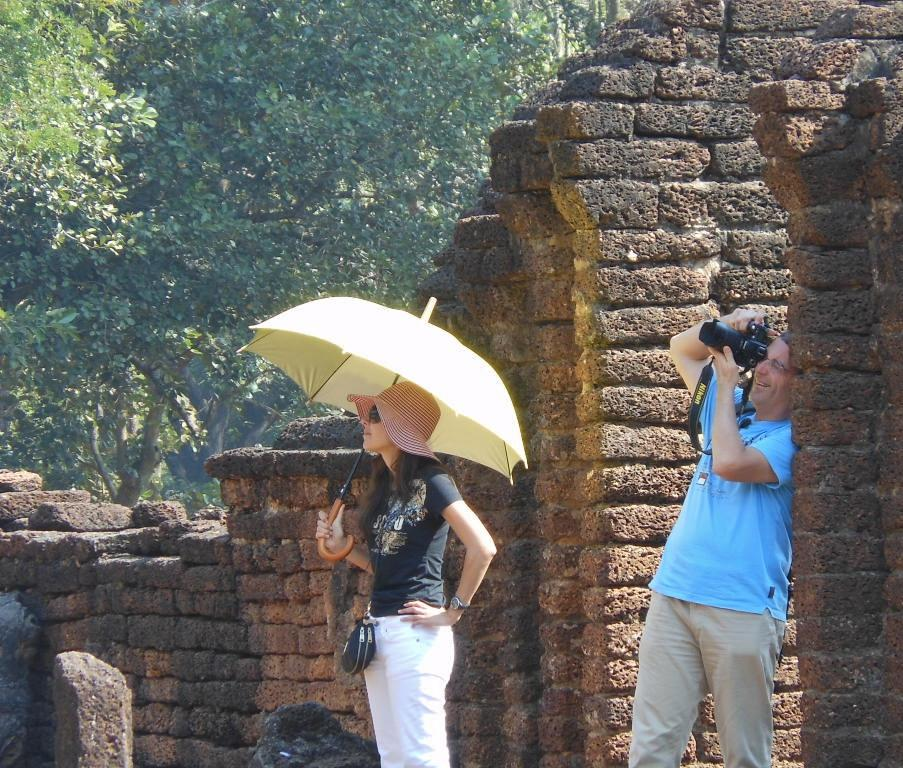Question: what color is the umbrella?
Choices:
A. Black.
B. Red.
C. Yellow.
D. Purple.
Answer with the letter. Answer: C Question: what material is the structure made of?
Choices:
A. Brick.
B. Concrete.
C. Wood.
D. Stone.
Answer with the letter. Answer: A Question: who is wearing a red checked floppy hat?
Choices:
A. The woman.
B. The teacher.
C. The girl.
D. The receptionist.
Answer with the letter. Answer: A Question: who is taking the picture?
Choices:
A. A man in a blue shirt.
B. A girl in a red top.
C. A woman in a green blouse.
D. A boy in a yellow shirt.
Answer with the letter. Answer: A Question: what is the man in the blue shirt doing?
Choices:
A. Getting a photo.
B. Capuring a memory.
C. Taking a snapshot.
D. Taking a picture.
Answer with the letter. Answer: D Question: what is the woman in white pants holding?
Choices:
A. A brown purse.
B. A white cell phone.
C. A yellow umbrella.
D. A bag.
Answer with the letter. Answer: C Question: what color is the umbrella?
Choices:
A. Pink.
B. Red.
C. Green.
D. Yellow.
Answer with the letter. Answer: D Question: what are the ruins made of?
Choices:
A. Red clay.
B. Weathered stone.
C. Old brick.
D. Pure gold.
Answer with the letter. Answer: B Question: what is behind the ruins?
Choices:
A. Leafy trees.
B. A blue lake.
C. A desert.
D. A grassy field.
Answer with the letter. Answer: A Question: where are the leafy trees?
Choices:
A. In front of the lake.
B. At the base of the mountain.
C. Behind the ruins.
D. In the forest.
Answer with the letter. Answer: C Question: who is visiting the ruins?
Choices:
A. A family.
B. Tourists.
C. Americans.
D. A couple.
Answer with the letter. Answer: D Question: what does the couple seem to be enjoying?
Choices:
A. Their trip to the ruins.
B. Each other.
C. The leafy trees.
D. The weather.
Answer with the letter. Answer: A Question: where does the woman wear a watch?
Choices:
A. On her left wrist.
B. On her right wrist.
C. Around her neck.
D. In her pocket.
Answer with the letter. Answer: A Question: what are the two people in casual clothing doing?
Choices:
A. Touring the city.
B. Going for a walk.
C. Shopping at the mall.
D. Looking off into the distance.
Answer with the letter. Answer: D Question: what is the man wearing?
Choices:
A. A trench coat.
B. A watch.
C. A dress suit.
D. Khakis.
Answer with the letter. Answer: D Question: who is wearing khakis?
Choices:
A. The golf attendant.
B. The concert usher.
C. The man.
D. The cashier.
Answer with the letter. Answer: C Question: what is lighting the ruins well?
Choices:
A. The sun.
B. Light.
C. Torches.
D. Flashlight.
Answer with the letter. Answer: A Question: who is looking off into the distance?
Choices:
A. Two people in casual clothing.
B. The artist.
C. The students.
D. The enginer.
Answer with the letter. Answer: A Question: what is the yellow umbrella blocking?
Choices:
A. The rain.
B. The snow.
C. The wind.
D. Bright sunshine.
Answer with the letter. Answer: D Question: how many people are there?
Choices:
A. Three.
B. Four.
C. Five.
D. Two.
Answer with the letter. Answer: D Question: what is the couple doing?
Choices:
A. Eating out.
B. Visiting the ruins.
C. Watching a movie.
D. Holding hands.
Answer with the letter. Answer: B Question: what do the reddish-brown bricks make up?
Choices:
A. The pyramid.
B. The ruins.
C. The building.
D. The house.
Answer with the letter. Answer: B Question: who seems to be enjoying the trip to the ruins?
Choices:
A. The family.
B. The tourists.
C. The couple.
D. The Americans.
Answer with the letter. Answer: C Question: who wears a watch on her left wrist?
Choices:
A. The woman.
B. The receptionist.
C. The right handed person.
D. The teacher.
Answer with the letter. Answer: A Question: who is wearing the sunglasses?
Choices:
A. The teenager.
B. The golfer.
C. The person working outside.
D. The woman.
Answer with the letter. Answer: D Question: what is lighted well by the sun?
Choices:
A. The forest.
B. The ruins.
C. The desert.
D. The ocean.
Answer with the letter. Answer: B Question: who are the tourists?
Choices:
A. The people.
B. The children.
C. The elderly.
D. The couples.
Answer with the letter. Answer: A Question: what are the people?
Choices:
A. Tourists.
B. Civilians.
C. Military.
D. Children.
Answer with the letter. Answer: A Question: what is the umbrella handle?
Choices:
A. Plastic.
B. Steel.
C. Leather.
D. Wooden.
Answer with the letter. Answer: D Question: what is wooden?
Choices:
A. The umbrella handle.
B. The desk.
C. The paddle.
D. The boat.
Answer with the letter. Answer: A Question: who is using a camera?
Choices:
A. The photographer.
B. The tourist.
C. The person.
D. The children.
Answer with the letter. Answer: C Question: what can you not see?
Choices:
A. What he is photographing.
B. The moon.
C. Pluto.
D. Behind me.
Answer with the letter. Answer: A 